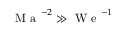Convert formula to latex. <formula><loc_0><loc_0><loc_500><loc_500>M a ^ { - 2 } \gg W e ^ { - 1 }</formula> 